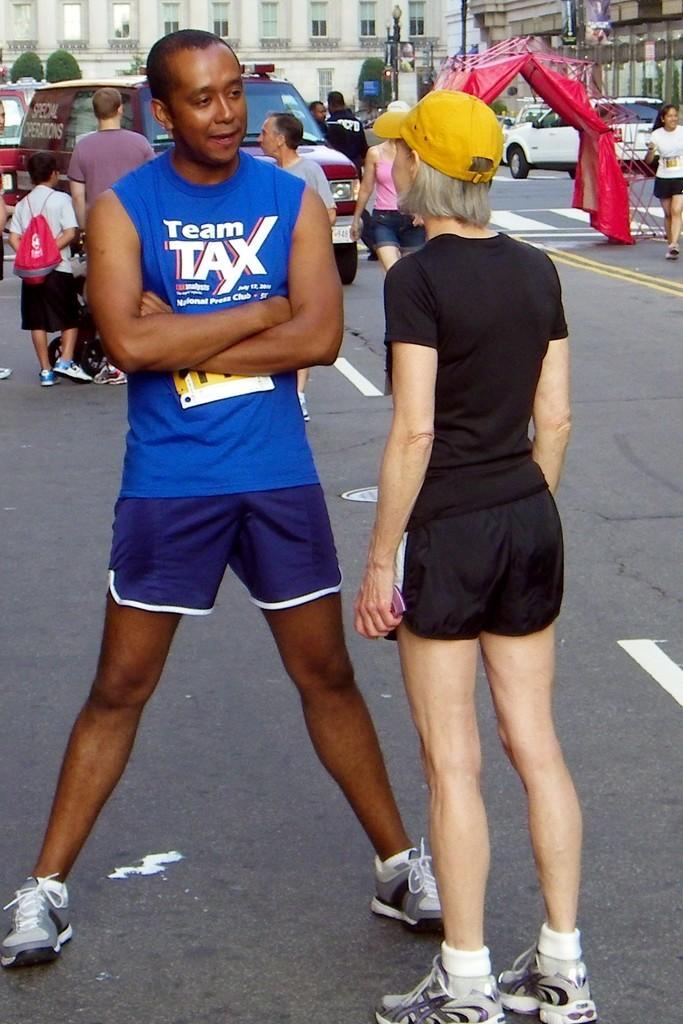Please provide a concise description of this image. This image is clicked on the road. There are many people walking on the road. There are vehicles moving on the road. In the foreground there is a man and a woman standing on the road. To the right there is a tent on the road. In the background there buildings, poles and hedges. 